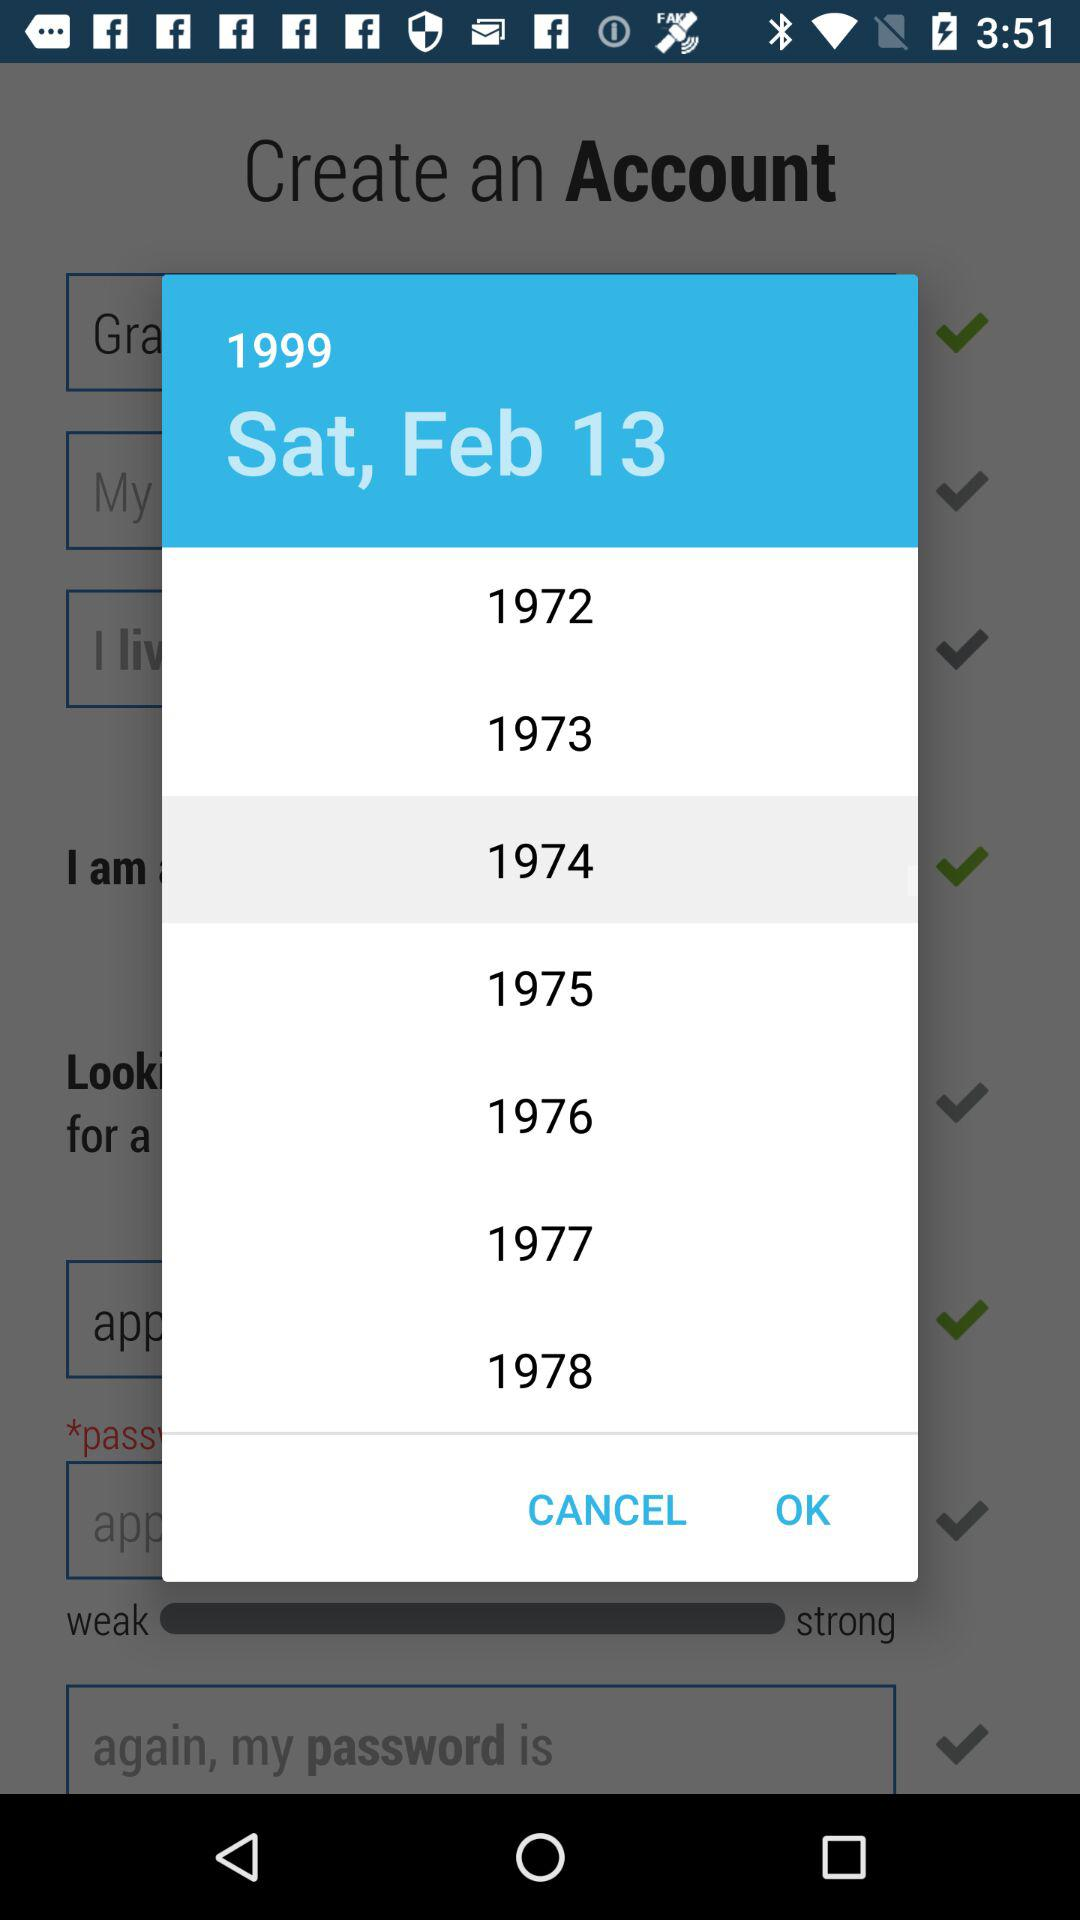Which date is selected? The selected date is Saturday, February 13, 1999. 